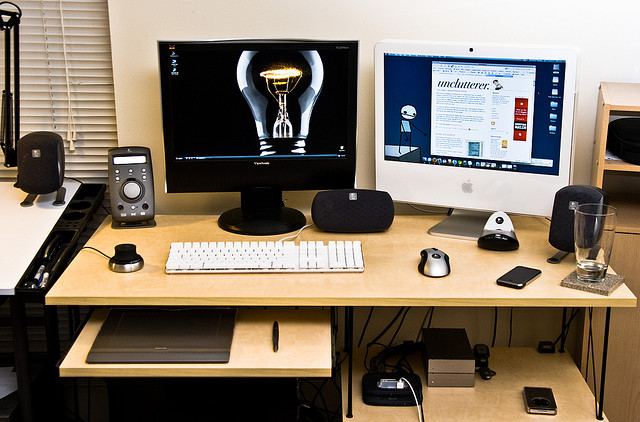Identify the text contained in this image. unclutterer 